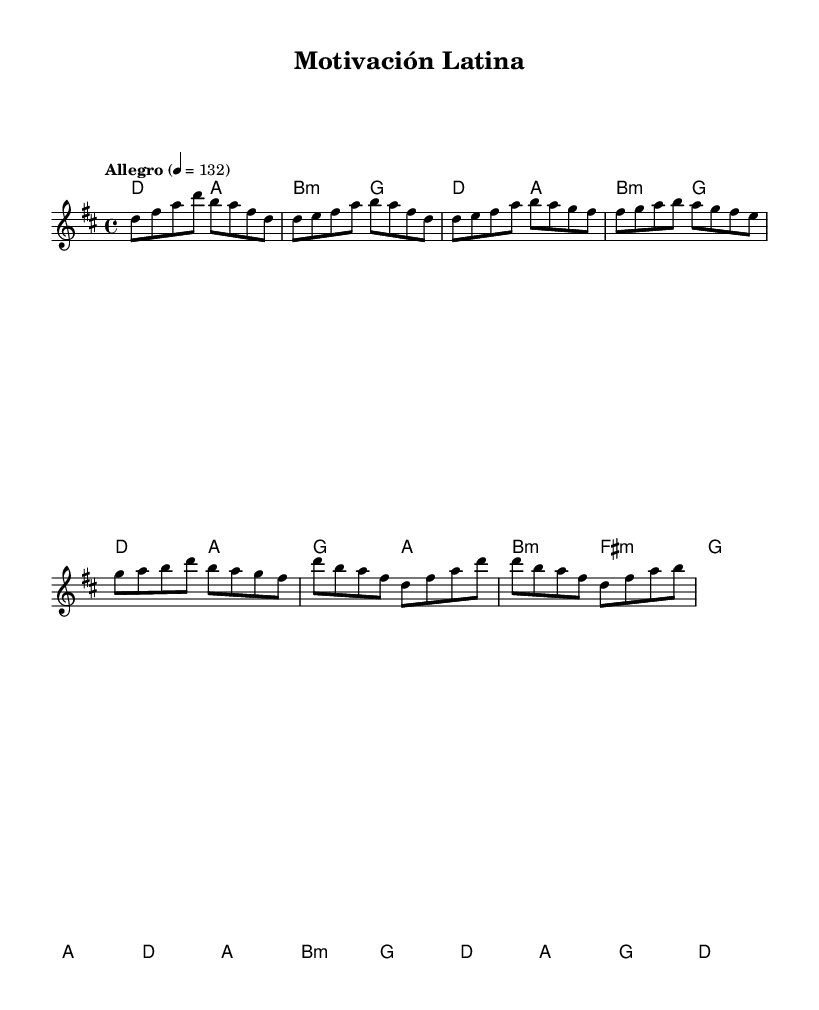What is the key signature of this music? The key signature is D major, which has two sharps (F# and C#). This is indicated at the beginning of the sheet music.
Answer: D major What is the time signature of this music? The time signature is 4/4, which means there are four beats in a measure and the quarter note gets one beat. This is also specified at the start of the piece.
Answer: 4/4 What is the tempo marking of this music? The tempo marking is "Allegro," which indicates a fast and lively pace. The tempo is set at 132 beats per minute, as specified at the beginning of the sheet music.
Answer: Allegro How many measures are in the chorus section? The chorus section consists of 4 measures. By counting the bars indicated in the score under the chorus segment, we find that it spans from the notes starting at the word "Chorus" to the end of the measures listed beneath.
Answer: 4 What is the time signature of the pre-chorus section? The pre-chorus maintains the same time signature of 4/4 that is established at the beginning of the piece, as this signature applies to all measures throughout the composition.
Answer: 4/4 What chords are used in the chorus section? The chorus section utilizes the chords D, A, B minor, and G. These chords progress through the measures for the chorus as indicated in the harmonic section, aligning with the melody notes.
Answer: D, A, B minor, G What is the general mood of this piece? The mood of this piece can be described as uplifting and energetic, characteristic of upbeat Latin pop music which promotes productivity and motivation during study sessions. The lively tempo and bright key contribute to this atmosphere.
Answer: Uplifting 